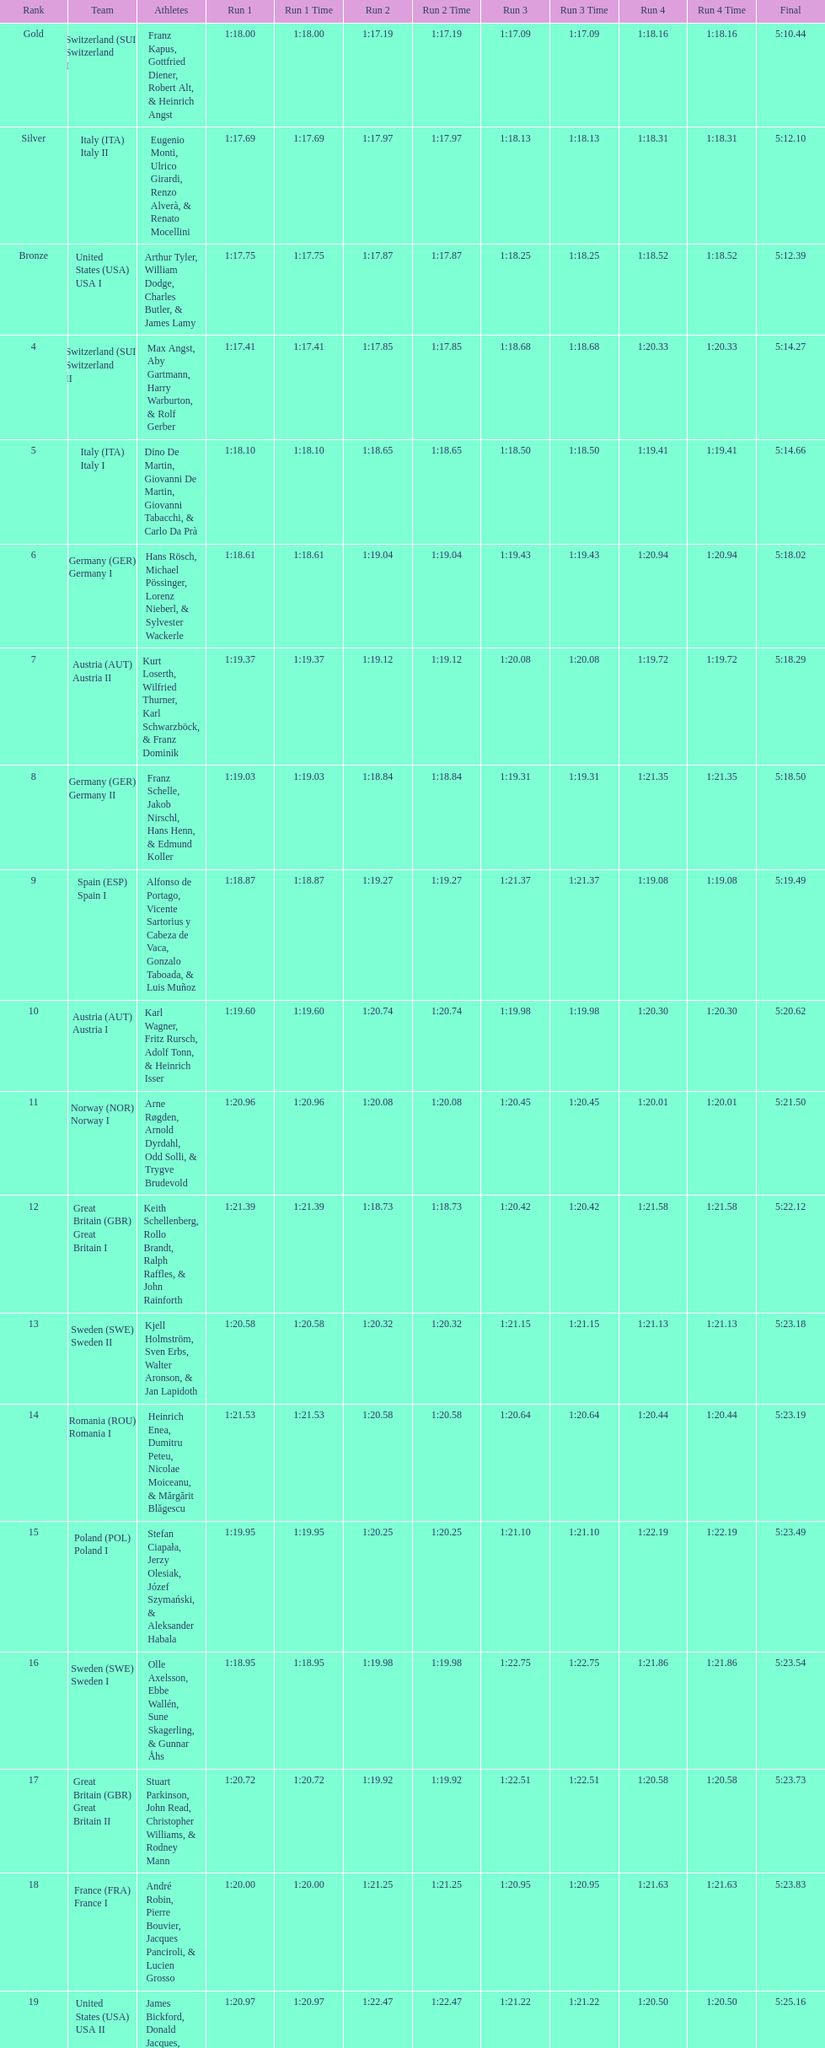Name a country that had 4 consecutive runs under 1:19. Switzerland. 